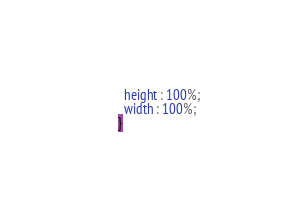Convert code to text. <code><loc_0><loc_0><loc_500><loc_500><_CSS_>  height : 100%;
  width : 100%;
}
</code> 